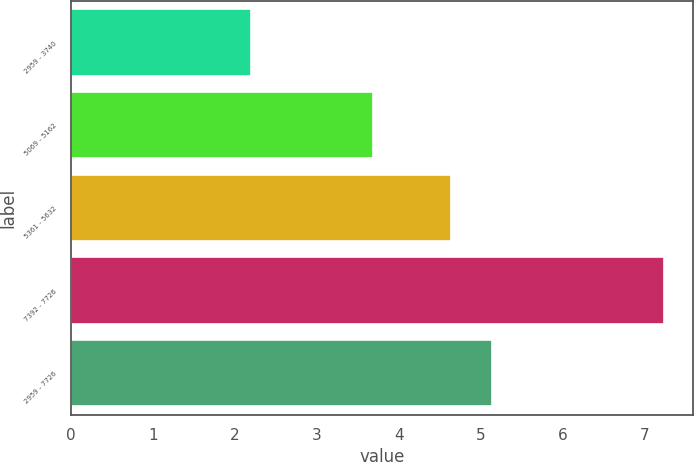Convert chart to OTSL. <chart><loc_0><loc_0><loc_500><loc_500><bar_chart><fcel>2959 - 3740<fcel>5069 - 5162<fcel>5361 - 5632<fcel>7392 - 7726<fcel>2959 - 7726<nl><fcel>2.2<fcel>3.69<fcel>4.63<fcel>7.23<fcel>5.13<nl></chart> 